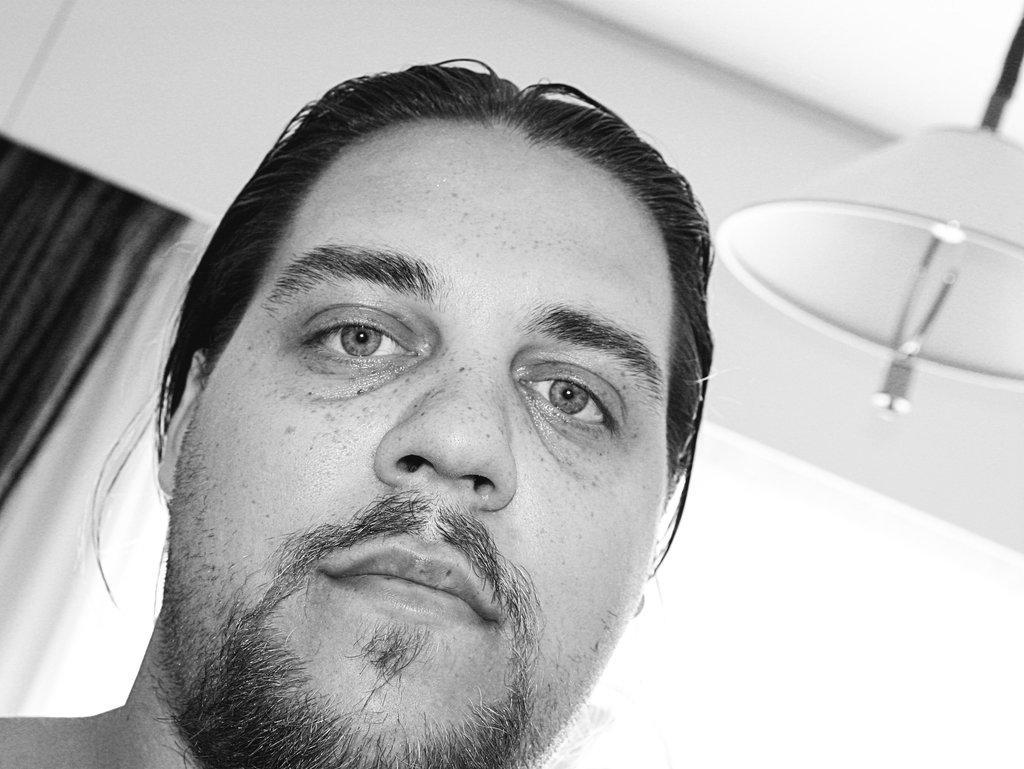Could you give a brief overview of what you see in this image? This is a black and white picture. In the background we can see the wall, cloth. We can see the face of a person. On the right side of the picture we can see an object. 